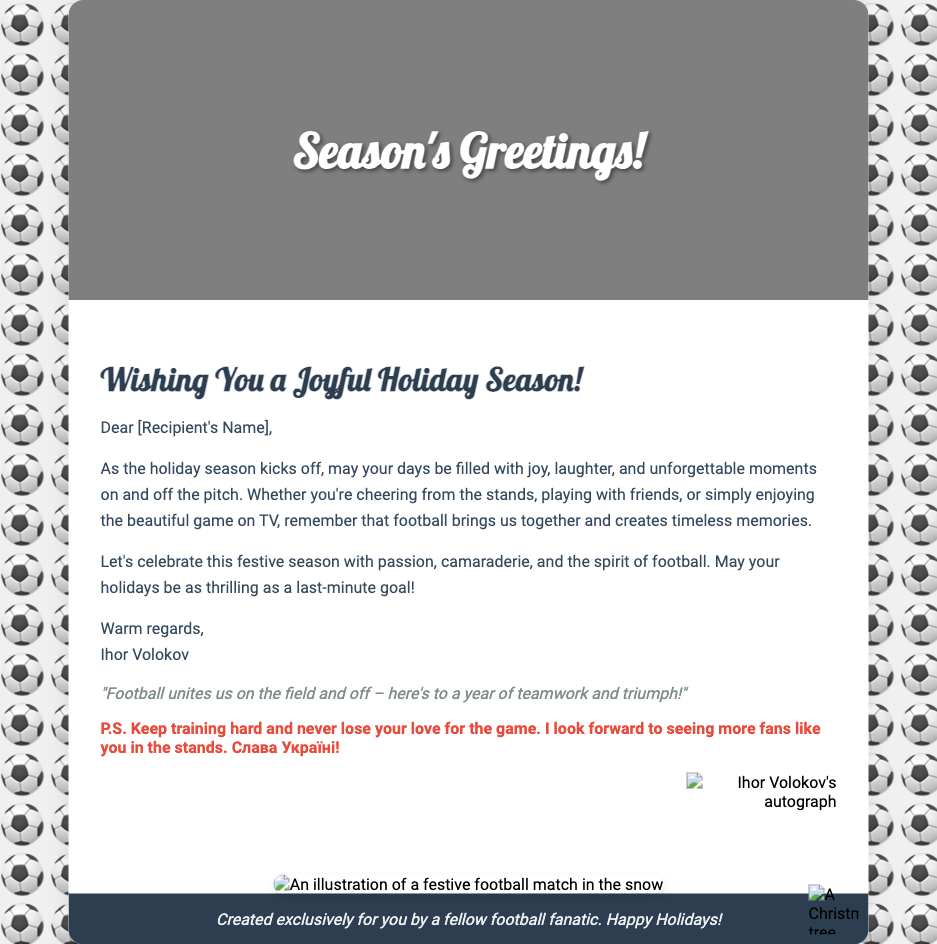What is the greeting on the cover? The greeting on the cover of the card is "Season's Greetings!"
Answer: Season's Greetings! Who is the sender of the card? The card is sent by Ihor Volokov, as indicated in the message.
Answer: Ihor Volokov What does the footer quote mention? The footer quote emphasizes the unifying aspect of football and the importance of teamwork.
Answer: "Football unites us on the field and off – here's to a year of teamwork and triumph!" What is the personal note's closing message? The personal note concludes with a strong message of support for Ukraine.
Answer: Слава Україні! What is featured in the holiday scene image? The holiday scene image depicts a festive football match in the snow.
Answer: A festive football match in the snow 